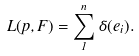<formula> <loc_0><loc_0><loc_500><loc_500>L ( p , F ) = \sum _ { 1 } ^ { n } \delta ( e _ { i } ) .</formula> 